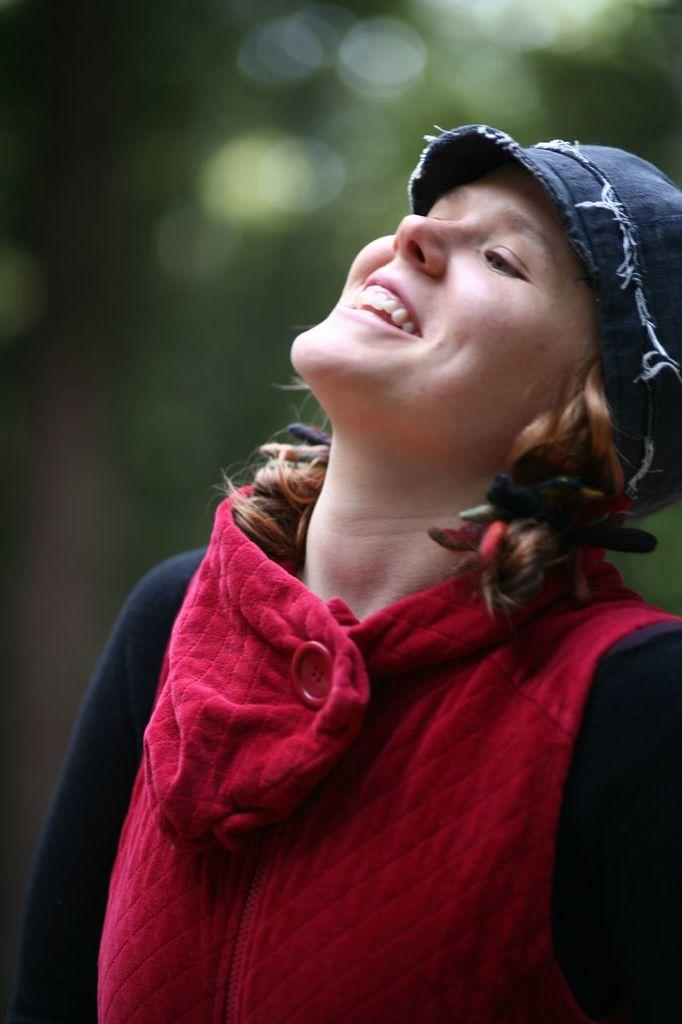Who is the main subject in the image? There is a lady in the image. What expression does the lady have? The lady is smiling. What type of clothing is the lady wearing on her upper body? The lady is wearing a jacket. What type of headwear is the lady wearing? The lady is wearing a cap. What type of seed can be seen growing on the side of the lady's cap in the image? There is no seed growing on the side of the lady's cap in the image. Can you describe the insect that is crawling on the lady's jacket in the image? There is no insect present on the lady's jacket in the image. 